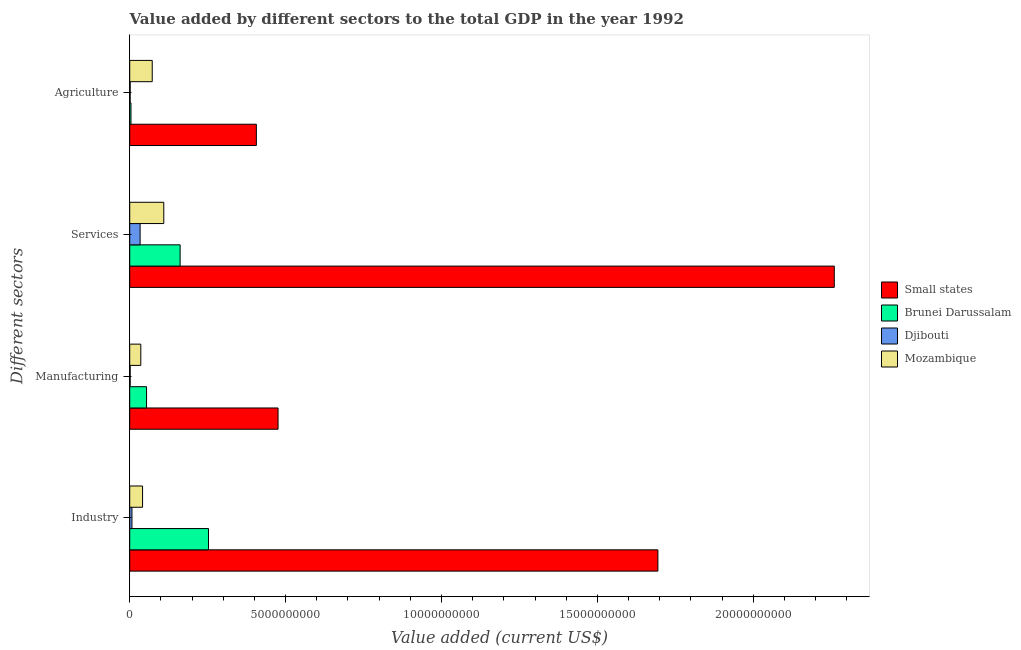Are the number of bars per tick equal to the number of legend labels?
Ensure brevity in your answer.  Yes. Are the number of bars on each tick of the Y-axis equal?
Offer a terse response. Yes. How many bars are there on the 3rd tick from the top?
Provide a short and direct response. 4. How many bars are there on the 3rd tick from the bottom?
Your answer should be compact. 4. What is the label of the 3rd group of bars from the top?
Ensure brevity in your answer.  Manufacturing. What is the value added by agricultural sector in Brunei Darussalam?
Provide a succinct answer. 4.04e+07. Across all countries, what is the maximum value added by manufacturing sector?
Provide a succinct answer. 4.76e+09. Across all countries, what is the minimum value added by manufacturing sector?
Give a very brief answer. 1.42e+07. In which country was the value added by services sector maximum?
Your response must be concise. Small states. In which country was the value added by industrial sector minimum?
Give a very brief answer. Djibouti. What is the total value added by services sector in the graph?
Keep it short and to the point. 2.56e+1. What is the difference between the value added by services sector in Mozambique and that in Brunei Darussalam?
Your answer should be very brief. -5.24e+08. What is the difference between the value added by services sector in Djibouti and the value added by manufacturing sector in Small states?
Offer a very short reply. -4.42e+09. What is the average value added by manufacturing sector per country?
Your answer should be compact. 1.42e+09. What is the difference between the value added by services sector and value added by agricultural sector in Brunei Darussalam?
Keep it short and to the point. 1.58e+09. In how many countries, is the value added by services sector greater than 11000000000 US$?
Ensure brevity in your answer.  1. What is the ratio of the value added by manufacturing sector in Mozambique to that in Djibouti?
Your answer should be very brief. 24.98. What is the difference between the highest and the second highest value added by industrial sector?
Your response must be concise. 1.44e+1. What is the difference between the highest and the lowest value added by agricultural sector?
Your answer should be compact. 4.05e+09. In how many countries, is the value added by agricultural sector greater than the average value added by agricultural sector taken over all countries?
Offer a terse response. 1. What does the 2nd bar from the top in Services represents?
Offer a terse response. Djibouti. What does the 2nd bar from the bottom in Manufacturing represents?
Your answer should be compact. Brunei Darussalam. Are all the bars in the graph horizontal?
Provide a succinct answer. Yes. What is the difference between two consecutive major ticks on the X-axis?
Provide a succinct answer. 5.00e+09. Are the values on the major ticks of X-axis written in scientific E-notation?
Your response must be concise. No. Does the graph contain any zero values?
Provide a short and direct response. No. Where does the legend appear in the graph?
Offer a very short reply. Center right. What is the title of the graph?
Keep it short and to the point. Value added by different sectors to the total GDP in the year 1992. What is the label or title of the X-axis?
Your response must be concise. Value added (current US$). What is the label or title of the Y-axis?
Keep it short and to the point. Different sectors. What is the Value added (current US$) of Small states in Industry?
Provide a short and direct response. 1.69e+1. What is the Value added (current US$) in Brunei Darussalam in Industry?
Offer a very short reply. 2.53e+09. What is the Value added (current US$) in Djibouti in Industry?
Provide a short and direct response. 7.17e+07. What is the Value added (current US$) of Mozambique in Industry?
Offer a very short reply. 4.12e+08. What is the Value added (current US$) of Small states in Manufacturing?
Offer a terse response. 4.76e+09. What is the Value added (current US$) of Brunei Darussalam in Manufacturing?
Provide a short and direct response. 5.39e+08. What is the Value added (current US$) in Djibouti in Manufacturing?
Ensure brevity in your answer.  1.42e+07. What is the Value added (current US$) in Mozambique in Manufacturing?
Your response must be concise. 3.55e+08. What is the Value added (current US$) of Small states in Services?
Keep it short and to the point. 2.26e+1. What is the Value added (current US$) in Brunei Darussalam in Services?
Your answer should be compact. 1.62e+09. What is the Value added (current US$) of Djibouti in Services?
Provide a short and direct response. 3.33e+08. What is the Value added (current US$) in Mozambique in Services?
Ensure brevity in your answer.  1.09e+09. What is the Value added (current US$) of Small states in Agriculture?
Offer a terse response. 4.06e+09. What is the Value added (current US$) of Brunei Darussalam in Agriculture?
Keep it short and to the point. 4.04e+07. What is the Value added (current US$) of Djibouti in Agriculture?
Offer a terse response. 1.38e+07. What is the Value added (current US$) in Mozambique in Agriculture?
Provide a succinct answer. 7.22e+08. Across all Different sectors, what is the maximum Value added (current US$) of Small states?
Your answer should be compact. 2.26e+1. Across all Different sectors, what is the maximum Value added (current US$) of Brunei Darussalam?
Your answer should be very brief. 2.53e+09. Across all Different sectors, what is the maximum Value added (current US$) of Djibouti?
Ensure brevity in your answer.  3.33e+08. Across all Different sectors, what is the maximum Value added (current US$) of Mozambique?
Your answer should be very brief. 1.09e+09. Across all Different sectors, what is the minimum Value added (current US$) in Small states?
Your answer should be compact. 4.06e+09. Across all Different sectors, what is the minimum Value added (current US$) of Brunei Darussalam?
Provide a short and direct response. 4.04e+07. Across all Different sectors, what is the minimum Value added (current US$) of Djibouti?
Your response must be concise. 1.38e+07. Across all Different sectors, what is the minimum Value added (current US$) in Mozambique?
Ensure brevity in your answer.  3.55e+08. What is the total Value added (current US$) in Small states in the graph?
Offer a very short reply. 4.84e+1. What is the total Value added (current US$) in Brunei Darussalam in the graph?
Give a very brief answer. 4.72e+09. What is the total Value added (current US$) in Djibouti in the graph?
Provide a short and direct response. 4.33e+08. What is the total Value added (current US$) of Mozambique in the graph?
Keep it short and to the point. 2.58e+09. What is the difference between the Value added (current US$) of Small states in Industry and that in Manufacturing?
Your answer should be very brief. 1.22e+1. What is the difference between the Value added (current US$) in Brunei Darussalam in Industry and that in Manufacturing?
Keep it short and to the point. 1.99e+09. What is the difference between the Value added (current US$) of Djibouti in Industry and that in Manufacturing?
Make the answer very short. 5.75e+07. What is the difference between the Value added (current US$) in Mozambique in Industry and that in Manufacturing?
Provide a short and direct response. 5.68e+07. What is the difference between the Value added (current US$) in Small states in Industry and that in Services?
Make the answer very short. -5.66e+09. What is the difference between the Value added (current US$) of Brunei Darussalam in Industry and that in Services?
Provide a succinct answer. 9.10e+08. What is the difference between the Value added (current US$) in Djibouti in Industry and that in Services?
Ensure brevity in your answer.  -2.61e+08. What is the difference between the Value added (current US$) in Mozambique in Industry and that in Services?
Give a very brief answer. -6.81e+08. What is the difference between the Value added (current US$) of Small states in Industry and that in Agriculture?
Offer a very short reply. 1.29e+1. What is the difference between the Value added (current US$) of Brunei Darussalam in Industry and that in Agriculture?
Make the answer very short. 2.49e+09. What is the difference between the Value added (current US$) in Djibouti in Industry and that in Agriculture?
Make the answer very short. 5.78e+07. What is the difference between the Value added (current US$) in Mozambique in Industry and that in Agriculture?
Your answer should be compact. -3.10e+08. What is the difference between the Value added (current US$) in Small states in Manufacturing and that in Services?
Make the answer very short. -1.78e+1. What is the difference between the Value added (current US$) in Brunei Darussalam in Manufacturing and that in Services?
Ensure brevity in your answer.  -1.08e+09. What is the difference between the Value added (current US$) in Djibouti in Manufacturing and that in Services?
Your answer should be compact. -3.19e+08. What is the difference between the Value added (current US$) of Mozambique in Manufacturing and that in Services?
Make the answer very short. -7.37e+08. What is the difference between the Value added (current US$) in Small states in Manufacturing and that in Agriculture?
Offer a terse response. 6.96e+08. What is the difference between the Value added (current US$) in Brunei Darussalam in Manufacturing and that in Agriculture?
Ensure brevity in your answer.  4.99e+08. What is the difference between the Value added (current US$) in Djibouti in Manufacturing and that in Agriculture?
Offer a very short reply. 3.71e+05. What is the difference between the Value added (current US$) of Mozambique in Manufacturing and that in Agriculture?
Your answer should be very brief. -3.67e+08. What is the difference between the Value added (current US$) of Small states in Services and that in Agriculture?
Give a very brief answer. 1.85e+1. What is the difference between the Value added (current US$) of Brunei Darussalam in Services and that in Agriculture?
Give a very brief answer. 1.58e+09. What is the difference between the Value added (current US$) of Djibouti in Services and that in Agriculture?
Make the answer very short. 3.19e+08. What is the difference between the Value added (current US$) in Mozambique in Services and that in Agriculture?
Offer a very short reply. 3.70e+08. What is the difference between the Value added (current US$) of Small states in Industry and the Value added (current US$) of Brunei Darussalam in Manufacturing?
Your answer should be compact. 1.64e+1. What is the difference between the Value added (current US$) of Small states in Industry and the Value added (current US$) of Djibouti in Manufacturing?
Make the answer very short. 1.69e+1. What is the difference between the Value added (current US$) in Small states in Industry and the Value added (current US$) in Mozambique in Manufacturing?
Offer a terse response. 1.66e+1. What is the difference between the Value added (current US$) of Brunei Darussalam in Industry and the Value added (current US$) of Djibouti in Manufacturing?
Make the answer very short. 2.51e+09. What is the difference between the Value added (current US$) in Brunei Darussalam in Industry and the Value added (current US$) in Mozambique in Manufacturing?
Offer a very short reply. 2.17e+09. What is the difference between the Value added (current US$) in Djibouti in Industry and the Value added (current US$) in Mozambique in Manufacturing?
Offer a terse response. -2.83e+08. What is the difference between the Value added (current US$) in Small states in Industry and the Value added (current US$) in Brunei Darussalam in Services?
Your answer should be compact. 1.53e+1. What is the difference between the Value added (current US$) in Small states in Industry and the Value added (current US$) in Djibouti in Services?
Your answer should be compact. 1.66e+1. What is the difference between the Value added (current US$) in Small states in Industry and the Value added (current US$) in Mozambique in Services?
Your answer should be compact. 1.58e+1. What is the difference between the Value added (current US$) of Brunei Darussalam in Industry and the Value added (current US$) of Djibouti in Services?
Provide a short and direct response. 2.19e+09. What is the difference between the Value added (current US$) in Brunei Darussalam in Industry and the Value added (current US$) in Mozambique in Services?
Your response must be concise. 1.43e+09. What is the difference between the Value added (current US$) in Djibouti in Industry and the Value added (current US$) in Mozambique in Services?
Provide a short and direct response. -1.02e+09. What is the difference between the Value added (current US$) in Small states in Industry and the Value added (current US$) in Brunei Darussalam in Agriculture?
Your response must be concise. 1.69e+1. What is the difference between the Value added (current US$) in Small states in Industry and the Value added (current US$) in Djibouti in Agriculture?
Offer a very short reply. 1.69e+1. What is the difference between the Value added (current US$) of Small states in Industry and the Value added (current US$) of Mozambique in Agriculture?
Provide a short and direct response. 1.62e+1. What is the difference between the Value added (current US$) of Brunei Darussalam in Industry and the Value added (current US$) of Djibouti in Agriculture?
Offer a terse response. 2.51e+09. What is the difference between the Value added (current US$) of Brunei Darussalam in Industry and the Value added (current US$) of Mozambique in Agriculture?
Offer a terse response. 1.80e+09. What is the difference between the Value added (current US$) of Djibouti in Industry and the Value added (current US$) of Mozambique in Agriculture?
Your answer should be compact. -6.50e+08. What is the difference between the Value added (current US$) of Small states in Manufacturing and the Value added (current US$) of Brunei Darussalam in Services?
Offer a terse response. 3.14e+09. What is the difference between the Value added (current US$) of Small states in Manufacturing and the Value added (current US$) of Djibouti in Services?
Your response must be concise. 4.42e+09. What is the difference between the Value added (current US$) in Small states in Manufacturing and the Value added (current US$) in Mozambique in Services?
Give a very brief answer. 3.67e+09. What is the difference between the Value added (current US$) of Brunei Darussalam in Manufacturing and the Value added (current US$) of Djibouti in Services?
Offer a very short reply. 2.06e+08. What is the difference between the Value added (current US$) in Brunei Darussalam in Manufacturing and the Value added (current US$) in Mozambique in Services?
Offer a terse response. -5.53e+08. What is the difference between the Value added (current US$) of Djibouti in Manufacturing and the Value added (current US$) of Mozambique in Services?
Your answer should be very brief. -1.08e+09. What is the difference between the Value added (current US$) in Small states in Manufacturing and the Value added (current US$) in Brunei Darussalam in Agriculture?
Offer a very short reply. 4.72e+09. What is the difference between the Value added (current US$) in Small states in Manufacturing and the Value added (current US$) in Djibouti in Agriculture?
Give a very brief answer. 4.74e+09. What is the difference between the Value added (current US$) of Small states in Manufacturing and the Value added (current US$) of Mozambique in Agriculture?
Make the answer very short. 4.04e+09. What is the difference between the Value added (current US$) of Brunei Darussalam in Manufacturing and the Value added (current US$) of Djibouti in Agriculture?
Your answer should be compact. 5.26e+08. What is the difference between the Value added (current US$) in Brunei Darussalam in Manufacturing and the Value added (current US$) in Mozambique in Agriculture?
Your answer should be very brief. -1.82e+08. What is the difference between the Value added (current US$) in Djibouti in Manufacturing and the Value added (current US$) in Mozambique in Agriculture?
Provide a succinct answer. -7.08e+08. What is the difference between the Value added (current US$) in Small states in Services and the Value added (current US$) in Brunei Darussalam in Agriculture?
Offer a terse response. 2.26e+1. What is the difference between the Value added (current US$) in Small states in Services and the Value added (current US$) in Djibouti in Agriculture?
Keep it short and to the point. 2.26e+1. What is the difference between the Value added (current US$) in Small states in Services and the Value added (current US$) in Mozambique in Agriculture?
Keep it short and to the point. 2.19e+1. What is the difference between the Value added (current US$) of Brunei Darussalam in Services and the Value added (current US$) of Djibouti in Agriculture?
Give a very brief answer. 1.60e+09. What is the difference between the Value added (current US$) in Brunei Darussalam in Services and the Value added (current US$) in Mozambique in Agriculture?
Make the answer very short. 8.94e+08. What is the difference between the Value added (current US$) of Djibouti in Services and the Value added (current US$) of Mozambique in Agriculture?
Give a very brief answer. -3.89e+08. What is the average Value added (current US$) in Small states per Different sectors?
Your response must be concise. 1.21e+1. What is the average Value added (current US$) in Brunei Darussalam per Different sectors?
Give a very brief answer. 1.18e+09. What is the average Value added (current US$) of Djibouti per Different sectors?
Offer a very short reply. 1.08e+08. What is the average Value added (current US$) of Mozambique per Different sectors?
Make the answer very short. 6.45e+08. What is the difference between the Value added (current US$) in Small states and Value added (current US$) in Brunei Darussalam in Industry?
Offer a very short reply. 1.44e+1. What is the difference between the Value added (current US$) in Small states and Value added (current US$) in Djibouti in Industry?
Keep it short and to the point. 1.69e+1. What is the difference between the Value added (current US$) in Small states and Value added (current US$) in Mozambique in Industry?
Your answer should be very brief. 1.65e+1. What is the difference between the Value added (current US$) of Brunei Darussalam and Value added (current US$) of Djibouti in Industry?
Offer a terse response. 2.46e+09. What is the difference between the Value added (current US$) of Brunei Darussalam and Value added (current US$) of Mozambique in Industry?
Offer a very short reply. 2.12e+09. What is the difference between the Value added (current US$) in Djibouti and Value added (current US$) in Mozambique in Industry?
Make the answer very short. -3.40e+08. What is the difference between the Value added (current US$) in Small states and Value added (current US$) in Brunei Darussalam in Manufacturing?
Make the answer very short. 4.22e+09. What is the difference between the Value added (current US$) in Small states and Value added (current US$) in Djibouti in Manufacturing?
Your answer should be compact. 4.74e+09. What is the difference between the Value added (current US$) in Small states and Value added (current US$) in Mozambique in Manufacturing?
Provide a succinct answer. 4.40e+09. What is the difference between the Value added (current US$) of Brunei Darussalam and Value added (current US$) of Djibouti in Manufacturing?
Provide a short and direct response. 5.25e+08. What is the difference between the Value added (current US$) in Brunei Darussalam and Value added (current US$) in Mozambique in Manufacturing?
Provide a short and direct response. 1.85e+08. What is the difference between the Value added (current US$) in Djibouti and Value added (current US$) in Mozambique in Manufacturing?
Your response must be concise. -3.41e+08. What is the difference between the Value added (current US$) of Small states and Value added (current US$) of Brunei Darussalam in Services?
Your answer should be compact. 2.10e+1. What is the difference between the Value added (current US$) in Small states and Value added (current US$) in Djibouti in Services?
Your answer should be very brief. 2.23e+1. What is the difference between the Value added (current US$) in Small states and Value added (current US$) in Mozambique in Services?
Keep it short and to the point. 2.15e+1. What is the difference between the Value added (current US$) in Brunei Darussalam and Value added (current US$) in Djibouti in Services?
Your answer should be compact. 1.28e+09. What is the difference between the Value added (current US$) in Brunei Darussalam and Value added (current US$) in Mozambique in Services?
Give a very brief answer. 5.24e+08. What is the difference between the Value added (current US$) in Djibouti and Value added (current US$) in Mozambique in Services?
Your response must be concise. -7.59e+08. What is the difference between the Value added (current US$) in Small states and Value added (current US$) in Brunei Darussalam in Agriculture?
Your answer should be very brief. 4.02e+09. What is the difference between the Value added (current US$) in Small states and Value added (current US$) in Djibouti in Agriculture?
Offer a very short reply. 4.05e+09. What is the difference between the Value added (current US$) in Small states and Value added (current US$) in Mozambique in Agriculture?
Your answer should be compact. 3.34e+09. What is the difference between the Value added (current US$) in Brunei Darussalam and Value added (current US$) in Djibouti in Agriculture?
Offer a terse response. 2.65e+07. What is the difference between the Value added (current US$) in Brunei Darussalam and Value added (current US$) in Mozambique in Agriculture?
Make the answer very short. -6.82e+08. What is the difference between the Value added (current US$) of Djibouti and Value added (current US$) of Mozambique in Agriculture?
Make the answer very short. -7.08e+08. What is the ratio of the Value added (current US$) of Small states in Industry to that in Manufacturing?
Your response must be concise. 3.56. What is the ratio of the Value added (current US$) of Brunei Darussalam in Industry to that in Manufacturing?
Offer a very short reply. 4.68. What is the ratio of the Value added (current US$) in Djibouti in Industry to that in Manufacturing?
Offer a very short reply. 5.04. What is the ratio of the Value added (current US$) in Mozambique in Industry to that in Manufacturing?
Keep it short and to the point. 1.16. What is the ratio of the Value added (current US$) of Small states in Industry to that in Services?
Offer a terse response. 0.75. What is the ratio of the Value added (current US$) in Brunei Darussalam in Industry to that in Services?
Keep it short and to the point. 1.56. What is the ratio of the Value added (current US$) in Djibouti in Industry to that in Services?
Your answer should be very brief. 0.22. What is the ratio of the Value added (current US$) of Mozambique in Industry to that in Services?
Offer a terse response. 0.38. What is the ratio of the Value added (current US$) of Small states in Industry to that in Agriculture?
Your answer should be compact. 4.17. What is the ratio of the Value added (current US$) in Brunei Darussalam in Industry to that in Agriculture?
Your response must be concise. 62.58. What is the ratio of the Value added (current US$) of Djibouti in Industry to that in Agriculture?
Provide a succinct answer. 5.18. What is the ratio of the Value added (current US$) in Mozambique in Industry to that in Agriculture?
Provide a short and direct response. 0.57. What is the ratio of the Value added (current US$) in Small states in Manufacturing to that in Services?
Offer a terse response. 0.21. What is the ratio of the Value added (current US$) in Brunei Darussalam in Manufacturing to that in Services?
Offer a terse response. 0.33. What is the ratio of the Value added (current US$) in Djibouti in Manufacturing to that in Services?
Your answer should be very brief. 0.04. What is the ratio of the Value added (current US$) in Mozambique in Manufacturing to that in Services?
Ensure brevity in your answer.  0.32. What is the ratio of the Value added (current US$) in Small states in Manufacturing to that in Agriculture?
Provide a short and direct response. 1.17. What is the ratio of the Value added (current US$) of Brunei Darussalam in Manufacturing to that in Agriculture?
Offer a terse response. 13.36. What is the ratio of the Value added (current US$) in Djibouti in Manufacturing to that in Agriculture?
Offer a very short reply. 1.03. What is the ratio of the Value added (current US$) of Mozambique in Manufacturing to that in Agriculture?
Your response must be concise. 0.49. What is the ratio of the Value added (current US$) in Small states in Services to that in Agriculture?
Your answer should be very brief. 5.56. What is the ratio of the Value added (current US$) of Brunei Darussalam in Services to that in Agriculture?
Give a very brief answer. 40.03. What is the ratio of the Value added (current US$) in Djibouti in Services to that in Agriculture?
Make the answer very short. 24.08. What is the ratio of the Value added (current US$) of Mozambique in Services to that in Agriculture?
Offer a terse response. 1.51. What is the difference between the highest and the second highest Value added (current US$) in Small states?
Offer a terse response. 5.66e+09. What is the difference between the highest and the second highest Value added (current US$) in Brunei Darussalam?
Your answer should be very brief. 9.10e+08. What is the difference between the highest and the second highest Value added (current US$) in Djibouti?
Provide a short and direct response. 2.61e+08. What is the difference between the highest and the second highest Value added (current US$) of Mozambique?
Ensure brevity in your answer.  3.70e+08. What is the difference between the highest and the lowest Value added (current US$) of Small states?
Keep it short and to the point. 1.85e+1. What is the difference between the highest and the lowest Value added (current US$) of Brunei Darussalam?
Make the answer very short. 2.49e+09. What is the difference between the highest and the lowest Value added (current US$) of Djibouti?
Give a very brief answer. 3.19e+08. What is the difference between the highest and the lowest Value added (current US$) of Mozambique?
Offer a very short reply. 7.37e+08. 